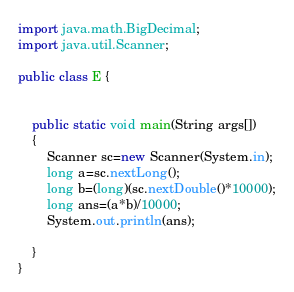Convert code to text. <code><loc_0><loc_0><loc_500><loc_500><_Java_>import java.math.BigDecimal;
import java.util.Scanner;

public class E {


    public static void main(String args[])
    {
        Scanner sc=new Scanner(System.in);
        long a=sc.nextLong();
        long b=(long)(sc.nextDouble()*10000);
        long ans=(a*b)/10000;
        System.out.println(ans);

    }
}
</code> 